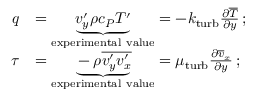Convert formula to latex. <formula><loc_0><loc_0><loc_500><loc_500>{ \begin{array} { r l } { q } & { = \underbrace { v _ { y } ^ { \prime } \rho c _ { P } T ^ { \prime } } _ { e x p e r i m e n t a l v a l u e } = - k _ { t u r b } { \frac { \partial { \overline { T } } } { \partial y } } \, ; } \\ { \tau } & { = \underbrace { - \rho { \overline { { v _ { y } ^ { \prime } v _ { x } ^ { \prime } } } } } _ { e x p e r i m e n t a l v a l u e } = \mu _ { t u r b } { \frac { \partial { \overline { v } } _ { x } } { \partial y } } \, ; } \end{array} }</formula> 